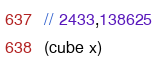<code> <loc_0><loc_0><loc_500><loc_500><_FORTRAN_>// 2433,138625
(cube x)
</code> 